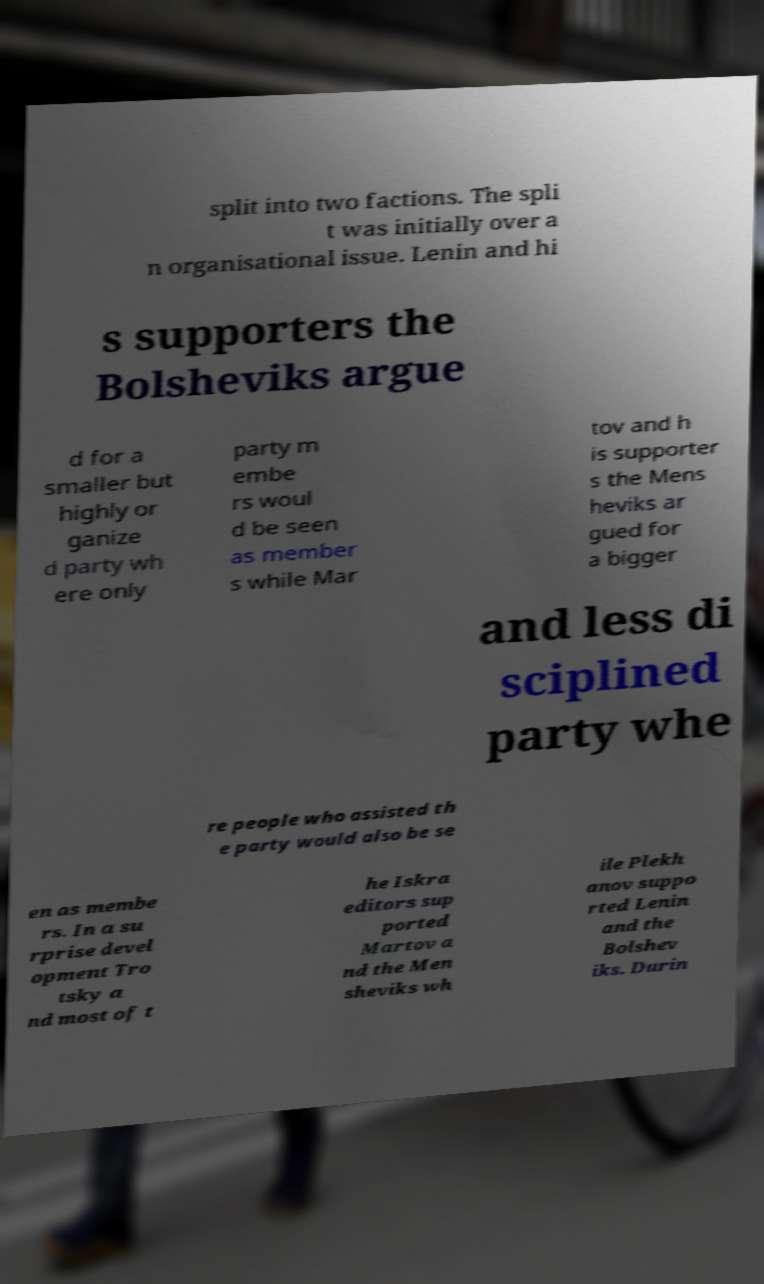Can you read and provide the text displayed in the image?This photo seems to have some interesting text. Can you extract and type it out for me? split into two factions. The spli t was initially over a n organisational issue. Lenin and hi s supporters the Bolsheviks argue d for a smaller but highly or ganize d party wh ere only party m embe rs woul d be seen as member s while Mar tov and h is supporter s the Mens heviks ar gued for a bigger and less di sciplined party whe re people who assisted th e party would also be se en as membe rs. In a su rprise devel opment Tro tsky a nd most of t he Iskra editors sup ported Martov a nd the Men sheviks wh ile Plekh anov suppo rted Lenin and the Bolshev iks. Durin 